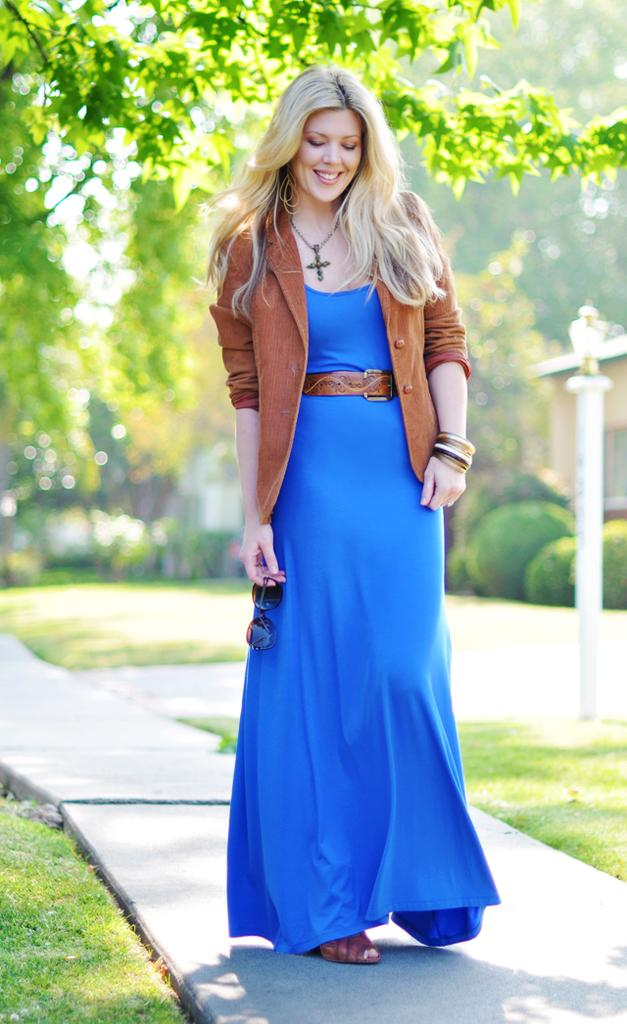Who is the main subject in the image? There is a woman in the image. What is the woman doing in the image? The woman is standing. What is the woman wearing in the image? The woman is wearing a brown coat and a blue dress. What object is the woman holding in the image? The woman is holding goggles. What type of natural scenery can be seen in the image? There are trees visible in the image. Who is the representative of the company in the image? There is no information provided about a company or a representative in the image. What type of bulb is hanging from the tree in the image? There is no bulb present in the image; it features a woman standing with trees in the background. 